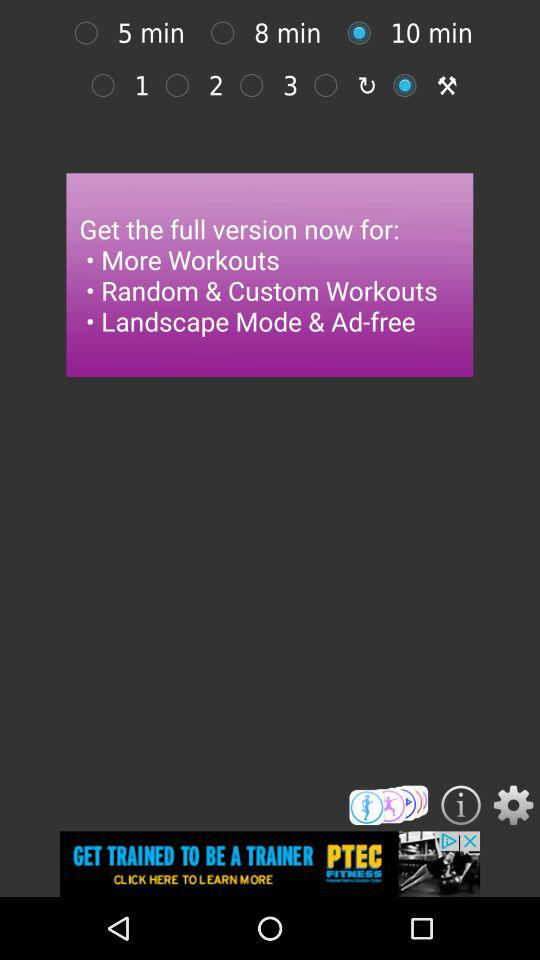How many minutes are there between the shortest and longest workout durations?
Answer the question using a single word or phrase. 5 